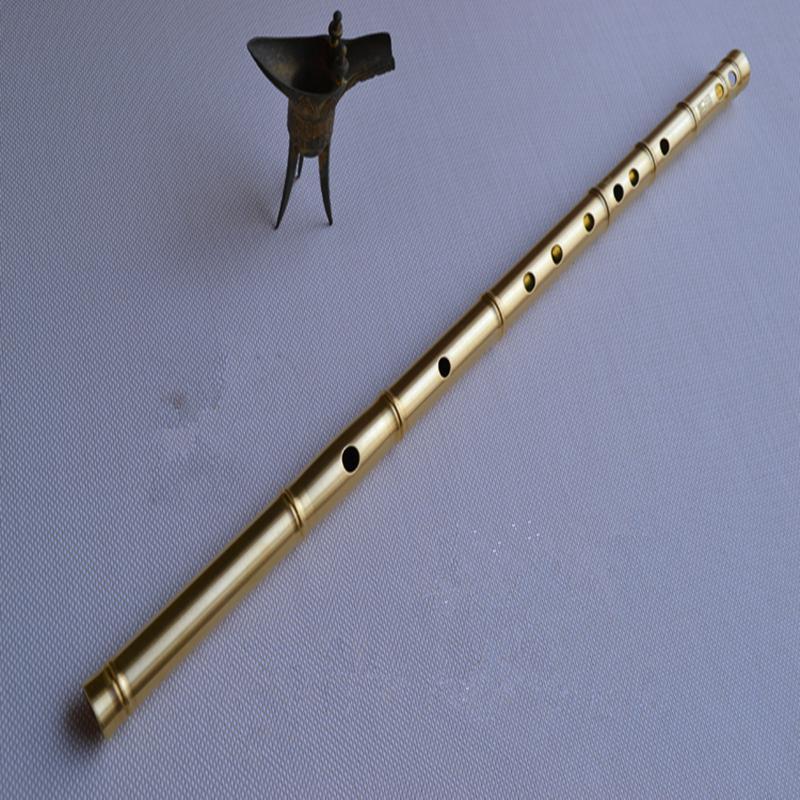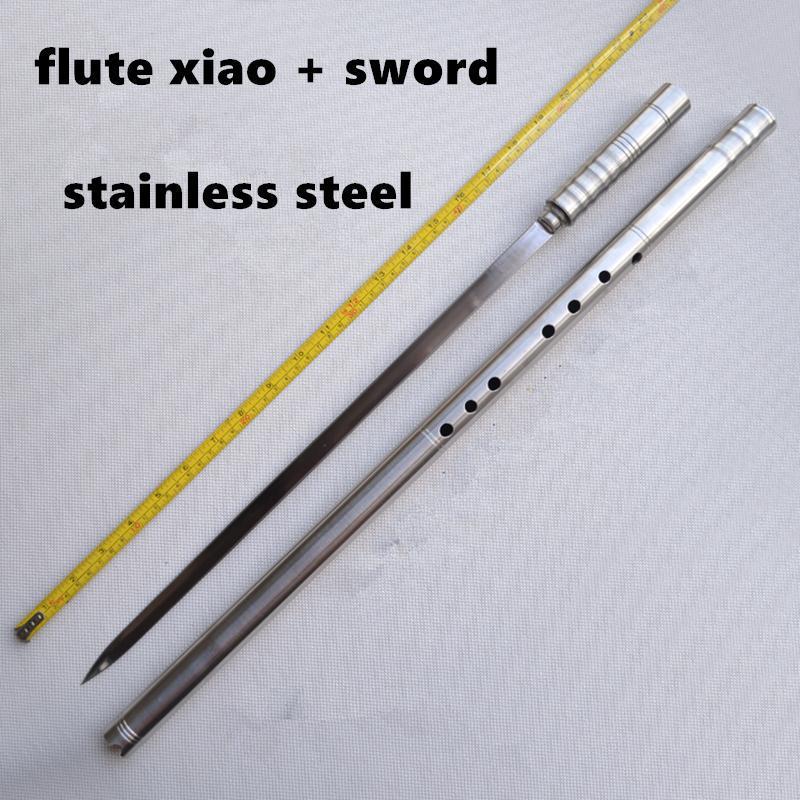The first image is the image on the left, the second image is the image on the right. Examine the images to the left and right. Is the description "The left image shows only a flute displayed at an angle, and the right image shows a measuring tape, a sword and a flute displayed diagonally." accurate? Answer yes or no. Yes. The first image is the image on the left, the second image is the image on the right. Examine the images to the left and right. Is the description "There are more instruments in the image on the right." accurate? Answer yes or no. Yes. 